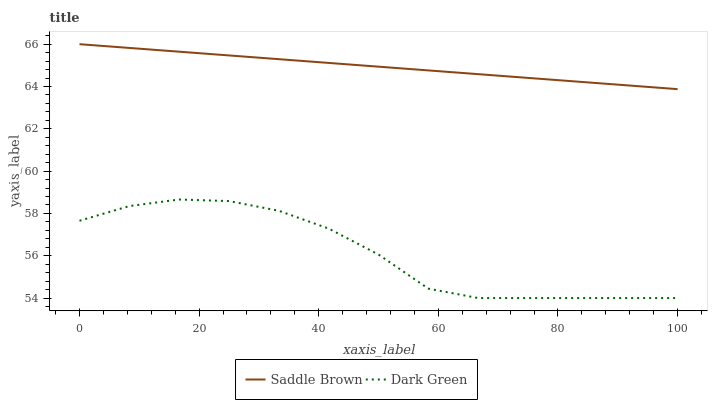Does Dark Green have the minimum area under the curve?
Answer yes or no. Yes. Does Saddle Brown have the maximum area under the curve?
Answer yes or no. Yes. Does Dark Green have the maximum area under the curve?
Answer yes or no. No. Is Saddle Brown the smoothest?
Answer yes or no. Yes. Is Dark Green the roughest?
Answer yes or no. Yes. Is Dark Green the smoothest?
Answer yes or no. No. Does Dark Green have the lowest value?
Answer yes or no. Yes. Does Saddle Brown have the highest value?
Answer yes or no. Yes. Does Dark Green have the highest value?
Answer yes or no. No. Is Dark Green less than Saddle Brown?
Answer yes or no. Yes. Is Saddle Brown greater than Dark Green?
Answer yes or no. Yes. Does Dark Green intersect Saddle Brown?
Answer yes or no. No. 